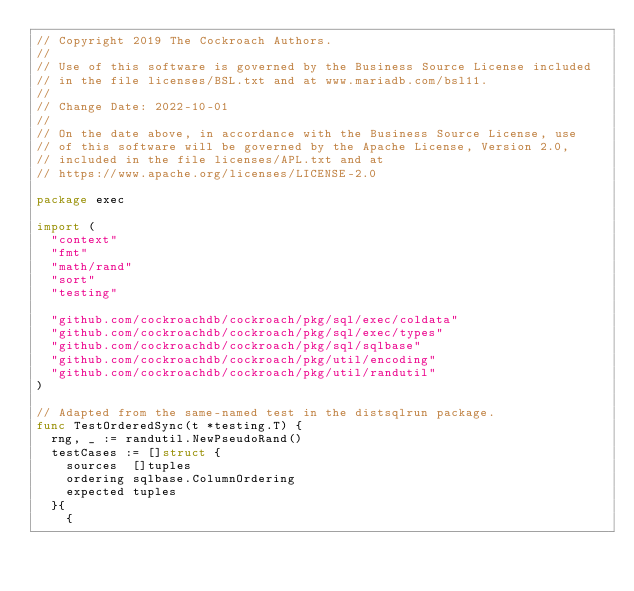Convert code to text. <code><loc_0><loc_0><loc_500><loc_500><_Go_>// Copyright 2019 The Cockroach Authors.
//
// Use of this software is governed by the Business Source License included
// in the file licenses/BSL.txt and at www.mariadb.com/bsl11.
//
// Change Date: 2022-10-01
//
// On the date above, in accordance with the Business Source License, use
// of this software will be governed by the Apache License, Version 2.0,
// included in the file licenses/APL.txt and at
// https://www.apache.org/licenses/LICENSE-2.0

package exec

import (
	"context"
	"fmt"
	"math/rand"
	"sort"
	"testing"

	"github.com/cockroachdb/cockroach/pkg/sql/exec/coldata"
	"github.com/cockroachdb/cockroach/pkg/sql/exec/types"
	"github.com/cockroachdb/cockroach/pkg/sql/sqlbase"
	"github.com/cockroachdb/cockroach/pkg/util/encoding"
	"github.com/cockroachdb/cockroach/pkg/util/randutil"
)

// Adapted from the same-named test in the distsqlrun package.
func TestOrderedSync(t *testing.T) {
	rng, _ := randutil.NewPseudoRand()
	testCases := []struct {
		sources  []tuples
		ordering sqlbase.ColumnOrdering
		expected tuples
	}{
		{</code> 